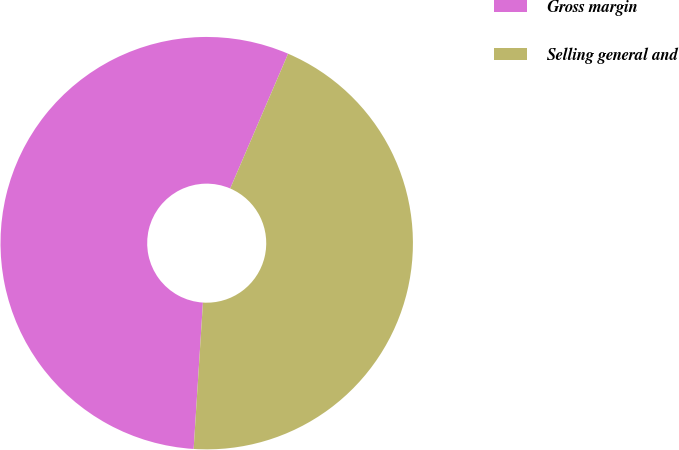Convert chart. <chart><loc_0><loc_0><loc_500><loc_500><pie_chart><fcel>Gross margin<fcel>Selling general and<nl><fcel>55.45%<fcel>44.55%<nl></chart> 